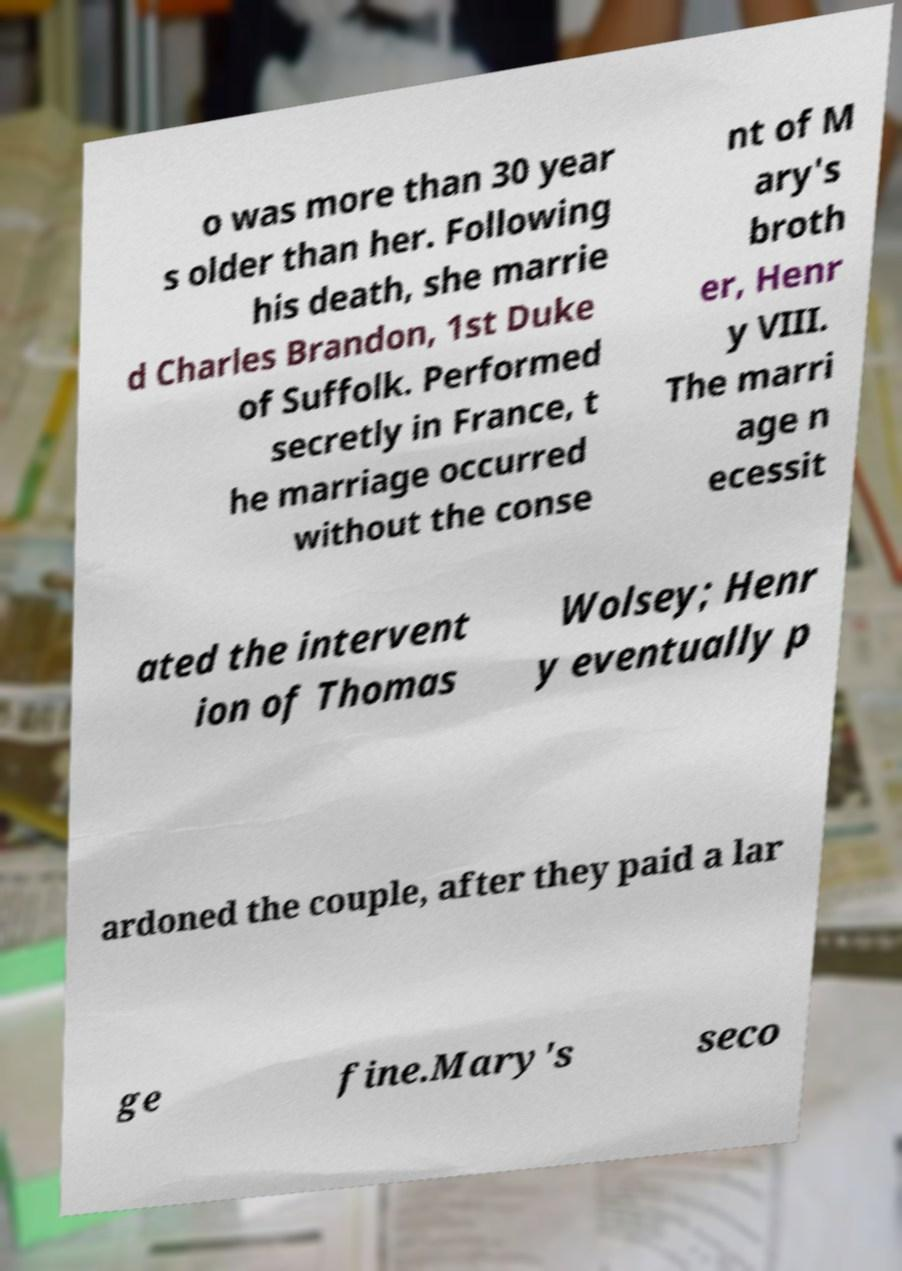Please read and relay the text visible in this image. What does it say? o was more than 30 year s older than her. Following his death, she marrie d Charles Brandon, 1st Duke of Suffolk. Performed secretly in France, t he marriage occurred without the conse nt of M ary's broth er, Henr y VIII. The marri age n ecessit ated the intervent ion of Thomas Wolsey; Henr y eventually p ardoned the couple, after they paid a lar ge fine.Mary's seco 